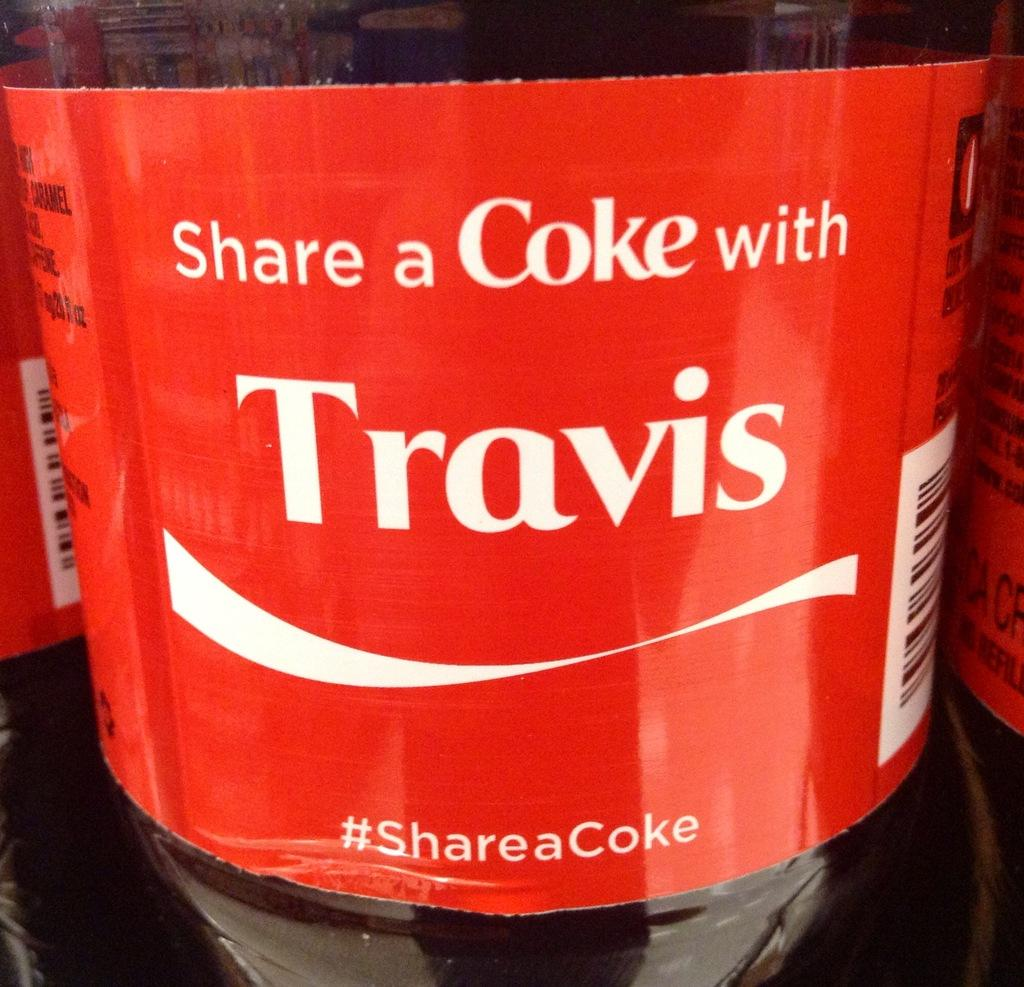<image>
Relay a brief, clear account of the picture shown. A bottle of Coke with the name Travis on it. 